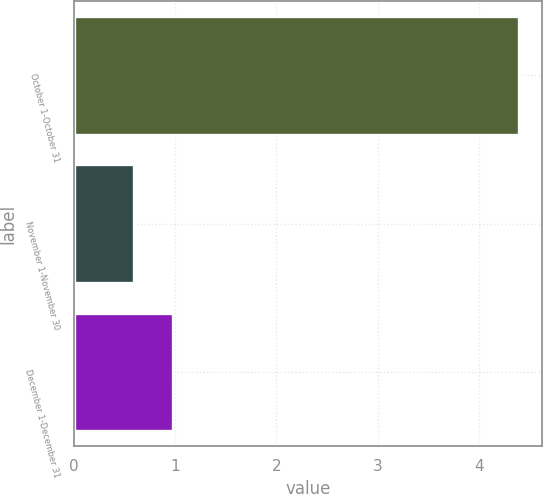Convert chart. <chart><loc_0><loc_0><loc_500><loc_500><bar_chart><fcel>October 1-October 31<fcel>November 1-November 30<fcel>December 1-December 31<nl><fcel>4.4<fcel>0.6<fcel>0.98<nl></chart> 